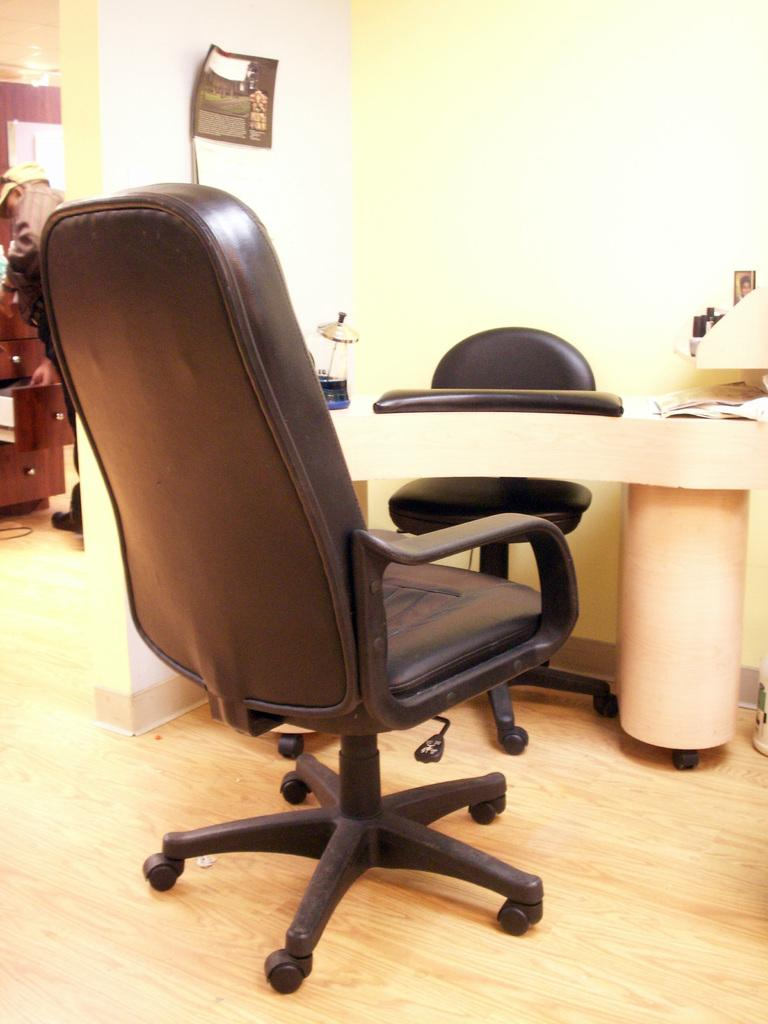What type of furniture is present in the image? There are chairs in the image. Can you describe the setting in the background of the image? There are racks and a person in the background of the image. What is on the wall in the image? There is a poster on a wall in the image. What type of protest is happening in the image? There is no protest present in the image. Can you describe the sink in the image? There is no sink present in the image. 